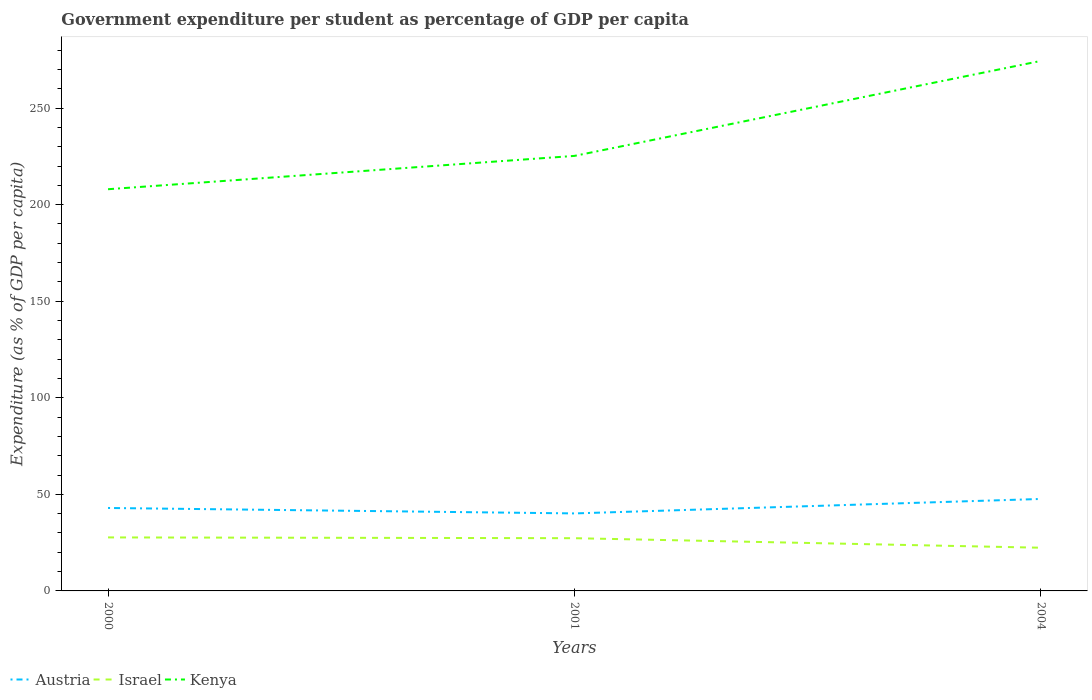How many different coloured lines are there?
Make the answer very short. 3. Does the line corresponding to Israel intersect with the line corresponding to Austria?
Give a very brief answer. No. Is the number of lines equal to the number of legend labels?
Your answer should be compact. Yes. Across all years, what is the maximum percentage of expenditure per student in Kenya?
Ensure brevity in your answer.  208. In which year was the percentage of expenditure per student in Israel maximum?
Provide a short and direct response. 2004. What is the total percentage of expenditure per student in Austria in the graph?
Your response must be concise. -4.67. What is the difference between the highest and the second highest percentage of expenditure per student in Israel?
Your response must be concise. 5.34. How many lines are there?
Provide a short and direct response. 3. What is the difference between two consecutive major ticks on the Y-axis?
Provide a short and direct response. 50. Are the values on the major ticks of Y-axis written in scientific E-notation?
Ensure brevity in your answer.  No. Where does the legend appear in the graph?
Make the answer very short. Bottom left. How many legend labels are there?
Your response must be concise. 3. What is the title of the graph?
Your answer should be very brief. Government expenditure per student as percentage of GDP per capita. Does "Bhutan" appear as one of the legend labels in the graph?
Your answer should be very brief. No. What is the label or title of the Y-axis?
Offer a very short reply. Expenditure (as % of GDP per capita). What is the Expenditure (as % of GDP per capita) of Austria in 2000?
Offer a terse response. 42.95. What is the Expenditure (as % of GDP per capita) in Israel in 2000?
Ensure brevity in your answer.  27.71. What is the Expenditure (as % of GDP per capita) of Kenya in 2000?
Offer a very short reply. 208. What is the Expenditure (as % of GDP per capita) of Austria in 2001?
Offer a terse response. 40.13. What is the Expenditure (as % of GDP per capita) in Israel in 2001?
Offer a very short reply. 27.3. What is the Expenditure (as % of GDP per capita) of Kenya in 2001?
Your answer should be very brief. 225.25. What is the Expenditure (as % of GDP per capita) in Austria in 2004?
Offer a terse response. 47.62. What is the Expenditure (as % of GDP per capita) in Israel in 2004?
Your response must be concise. 22.37. What is the Expenditure (as % of GDP per capita) of Kenya in 2004?
Give a very brief answer. 274.43. Across all years, what is the maximum Expenditure (as % of GDP per capita) of Austria?
Make the answer very short. 47.62. Across all years, what is the maximum Expenditure (as % of GDP per capita) in Israel?
Offer a very short reply. 27.71. Across all years, what is the maximum Expenditure (as % of GDP per capita) of Kenya?
Your response must be concise. 274.43. Across all years, what is the minimum Expenditure (as % of GDP per capita) of Austria?
Make the answer very short. 40.13. Across all years, what is the minimum Expenditure (as % of GDP per capita) of Israel?
Provide a short and direct response. 22.37. Across all years, what is the minimum Expenditure (as % of GDP per capita) of Kenya?
Your answer should be compact. 208. What is the total Expenditure (as % of GDP per capita) of Austria in the graph?
Your answer should be compact. 130.7. What is the total Expenditure (as % of GDP per capita) of Israel in the graph?
Provide a short and direct response. 77.38. What is the total Expenditure (as % of GDP per capita) in Kenya in the graph?
Ensure brevity in your answer.  707.68. What is the difference between the Expenditure (as % of GDP per capita) in Austria in 2000 and that in 2001?
Ensure brevity in your answer.  2.82. What is the difference between the Expenditure (as % of GDP per capita) in Israel in 2000 and that in 2001?
Your answer should be compact. 0.4. What is the difference between the Expenditure (as % of GDP per capita) of Kenya in 2000 and that in 2001?
Provide a short and direct response. -17.26. What is the difference between the Expenditure (as % of GDP per capita) of Austria in 2000 and that in 2004?
Ensure brevity in your answer.  -4.67. What is the difference between the Expenditure (as % of GDP per capita) of Israel in 2000 and that in 2004?
Make the answer very short. 5.34. What is the difference between the Expenditure (as % of GDP per capita) in Kenya in 2000 and that in 2004?
Offer a terse response. -66.44. What is the difference between the Expenditure (as % of GDP per capita) of Austria in 2001 and that in 2004?
Keep it short and to the point. -7.49. What is the difference between the Expenditure (as % of GDP per capita) in Israel in 2001 and that in 2004?
Your answer should be very brief. 4.94. What is the difference between the Expenditure (as % of GDP per capita) of Kenya in 2001 and that in 2004?
Your answer should be very brief. -49.18. What is the difference between the Expenditure (as % of GDP per capita) in Austria in 2000 and the Expenditure (as % of GDP per capita) in Israel in 2001?
Make the answer very short. 15.65. What is the difference between the Expenditure (as % of GDP per capita) of Austria in 2000 and the Expenditure (as % of GDP per capita) of Kenya in 2001?
Offer a very short reply. -182.3. What is the difference between the Expenditure (as % of GDP per capita) in Israel in 2000 and the Expenditure (as % of GDP per capita) in Kenya in 2001?
Offer a terse response. -197.55. What is the difference between the Expenditure (as % of GDP per capita) of Austria in 2000 and the Expenditure (as % of GDP per capita) of Israel in 2004?
Ensure brevity in your answer.  20.58. What is the difference between the Expenditure (as % of GDP per capita) of Austria in 2000 and the Expenditure (as % of GDP per capita) of Kenya in 2004?
Your answer should be compact. -231.48. What is the difference between the Expenditure (as % of GDP per capita) of Israel in 2000 and the Expenditure (as % of GDP per capita) of Kenya in 2004?
Make the answer very short. -246.73. What is the difference between the Expenditure (as % of GDP per capita) of Austria in 2001 and the Expenditure (as % of GDP per capita) of Israel in 2004?
Your answer should be very brief. 17.76. What is the difference between the Expenditure (as % of GDP per capita) in Austria in 2001 and the Expenditure (as % of GDP per capita) in Kenya in 2004?
Your answer should be compact. -234.3. What is the difference between the Expenditure (as % of GDP per capita) in Israel in 2001 and the Expenditure (as % of GDP per capita) in Kenya in 2004?
Offer a very short reply. -247.13. What is the average Expenditure (as % of GDP per capita) of Austria per year?
Keep it short and to the point. 43.57. What is the average Expenditure (as % of GDP per capita) of Israel per year?
Provide a short and direct response. 25.79. What is the average Expenditure (as % of GDP per capita) in Kenya per year?
Give a very brief answer. 235.89. In the year 2000, what is the difference between the Expenditure (as % of GDP per capita) in Austria and Expenditure (as % of GDP per capita) in Israel?
Ensure brevity in your answer.  15.24. In the year 2000, what is the difference between the Expenditure (as % of GDP per capita) of Austria and Expenditure (as % of GDP per capita) of Kenya?
Your answer should be very brief. -165.05. In the year 2000, what is the difference between the Expenditure (as % of GDP per capita) in Israel and Expenditure (as % of GDP per capita) in Kenya?
Ensure brevity in your answer.  -180.29. In the year 2001, what is the difference between the Expenditure (as % of GDP per capita) in Austria and Expenditure (as % of GDP per capita) in Israel?
Provide a succinct answer. 12.83. In the year 2001, what is the difference between the Expenditure (as % of GDP per capita) in Austria and Expenditure (as % of GDP per capita) in Kenya?
Offer a very short reply. -185.12. In the year 2001, what is the difference between the Expenditure (as % of GDP per capita) of Israel and Expenditure (as % of GDP per capita) of Kenya?
Provide a succinct answer. -197.95. In the year 2004, what is the difference between the Expenditure (as % of GDP per capita) in Austria and Expenditure (as % of GDP per capita) in Israel?
Your answer should be compact. 25.25. In the year 2004, what is the difference between the Expenditure (as % of GDP per capita) of Austria and Expenditure (as % of GDP per capita) of Kenya?
Provide a succinct answer. -226.81. In the year 2004, what is the difference between the Expenditure (as % of GDP per capita) in Israel and Expenditure (as % of GDP per capita) in Kenya?
Your answer should be very brief. -252.07. What is the ratio of the Expenditure (as % of GDP per capita) of Austria in 2000 to that in 2001?
Offer a very short reply. 1.07. What is the ratio of the Expenditure (as % of GDP per capita) of Israel in 2000 to that in 2001?
Your response must be concise. 1.01. What is the ratio of the Expenditure (as % of GDP per capita) in Kenya in 2000 to that in 2001?
Provide a succinct answer. 0.92. What is the ratio of the Expenditure (as % of GDP per capita) of Austria in 2000 to that in 2004?
Your answer should be very brief. 0.9. What is the ratio of the Expenditure (as % of GDP per capita) in Israel in 2000 to that in 2004?
Offer a terse response. 1.24. What is the ratio of the Expenditure (as % of GDP per capita) in Kenya in 2000 to that in 2004?
Offer a very short reply. 0.76. What is the ratio of the Expenditure (as % of GDP per capita) of Austria in 2001 to that in 2004?
Your answer should be compact. 0.84. What is the ratio of the Expenditure (as % of GDP per capita) of Israel in 2001 to that in 2004?
Your response must be concise. 1.22. What is the ratio of the Expenditure (as % of GDP per capita) in Kenya in 2001 to that in 2004?
Your answer should be compact. 0.82. What is the difference between the highest and the second highest Expenditure (as % of GDP per capita) of Austria?
Provide a succinct answer. 4.67. What is the difference between the highest and the second highest Expenditure (as % of GDP per capita) of Israel?
Give a very brief answer. 0.4. What is the difference between the highest and the second highest Expenditure (as % of GDP per capita) in Kenya?
Make the answer very short. 49.18. What is the difference between the highest and the lowest Expenditure (as % of GDP per capita) in Austria?
Your answer should be very brief. 7.49. What is the difference between the highest and the lowest Expenditure (as % of GDP per capita) of Israel?
Your answer should be compact. 5.34. What is the difference between the highest and the lowest Expenditure (as % of GDP per capita) of Kenya?
Provide a short and direct response. 66.44. 